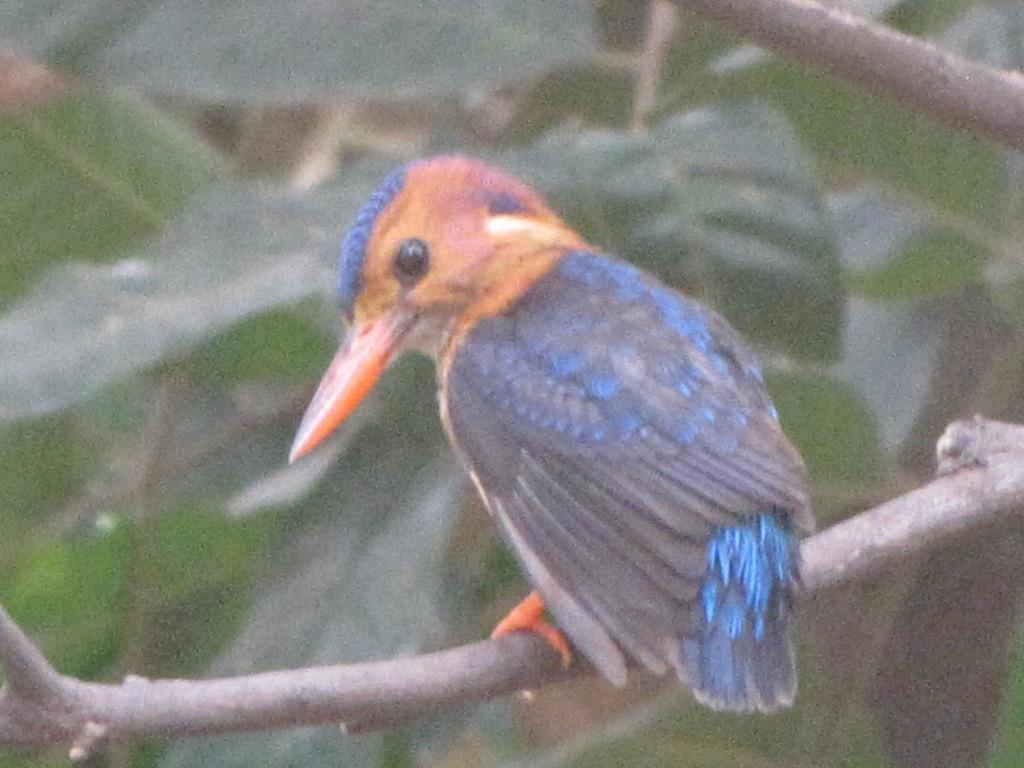In one or two sentences, can you explain what this image depicts? In this picture there is a bird which is standing on this tree branch. In the background i can see the leaves. 